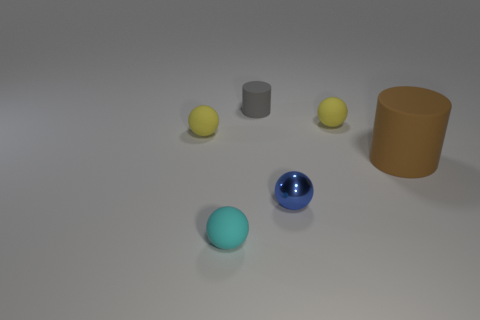Subtract all cyan rubber balls. How many balls are left? 3 Add 2 cyan rubber balls. How many objects exist? 8 Subtract all brown cylinders. How many cylinders are left? 1 Subtract all spheres. How many objects are left? 2 Subtract all brown spheres. How many brown cylinders are left? 1 Subtract 1 cylinders. How many cylinders are left? 1 Subtract all small yellow objects. Subtract all tiny balls. How many objects are left? 0 Add 3 small yellow rubber spheres. How many small yellow rubber spheres are left? 5 Add 6 cyan rubber objects. How many cyan rubber objects exist? 7 Subtract 0 cyan blocks. How many objects are left? 6 